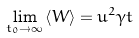<formula> <loc_0><loc_0><loc_500><loc_500>\lim _ { t _ { 0 } \to \infty } \left < W \right > = u ^ { 2 } \gamma t</formula> 